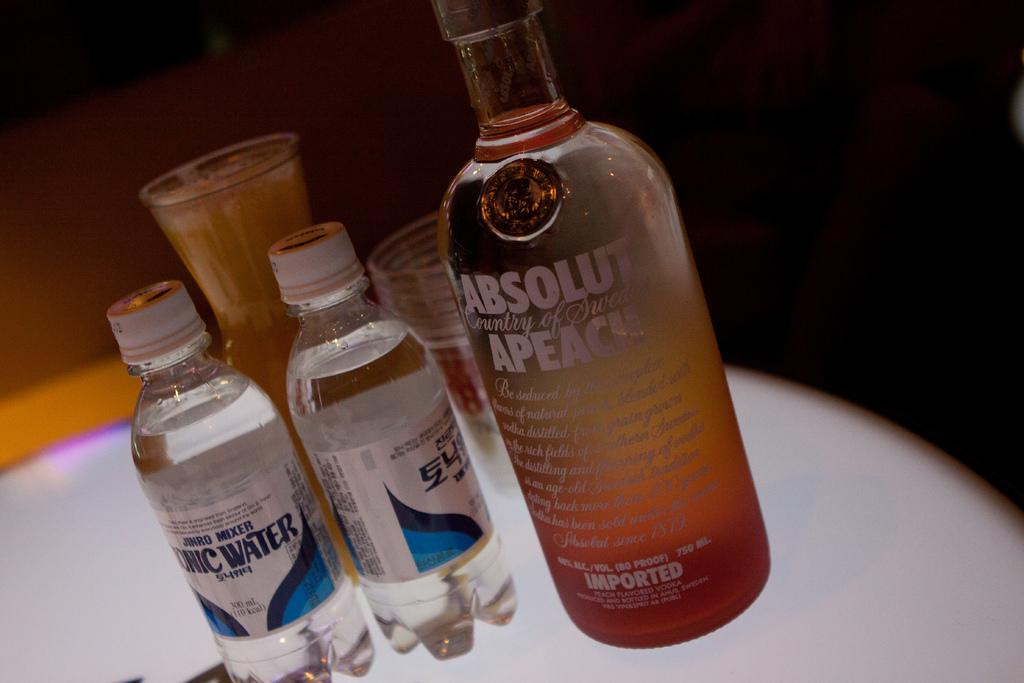<image>
Offer a succinct explanation of the picture presented. some vodka bottles with the word apeace on one of them 